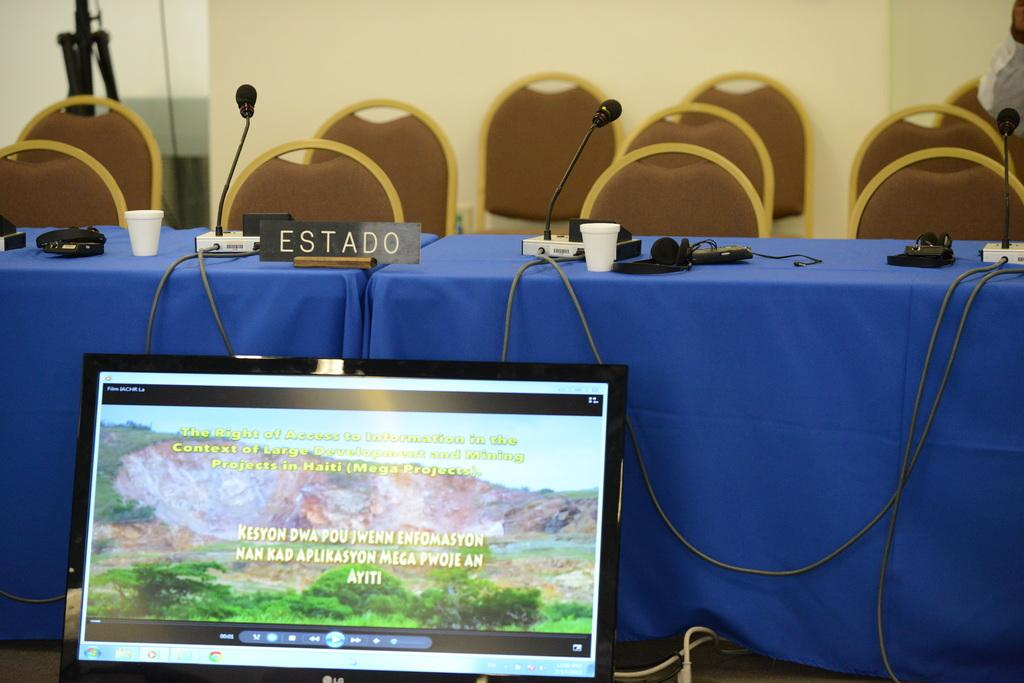Provide a one-sentence caption for the provided image. A Spanish language nameplate sits on a table covered with a blue tablecloth. 